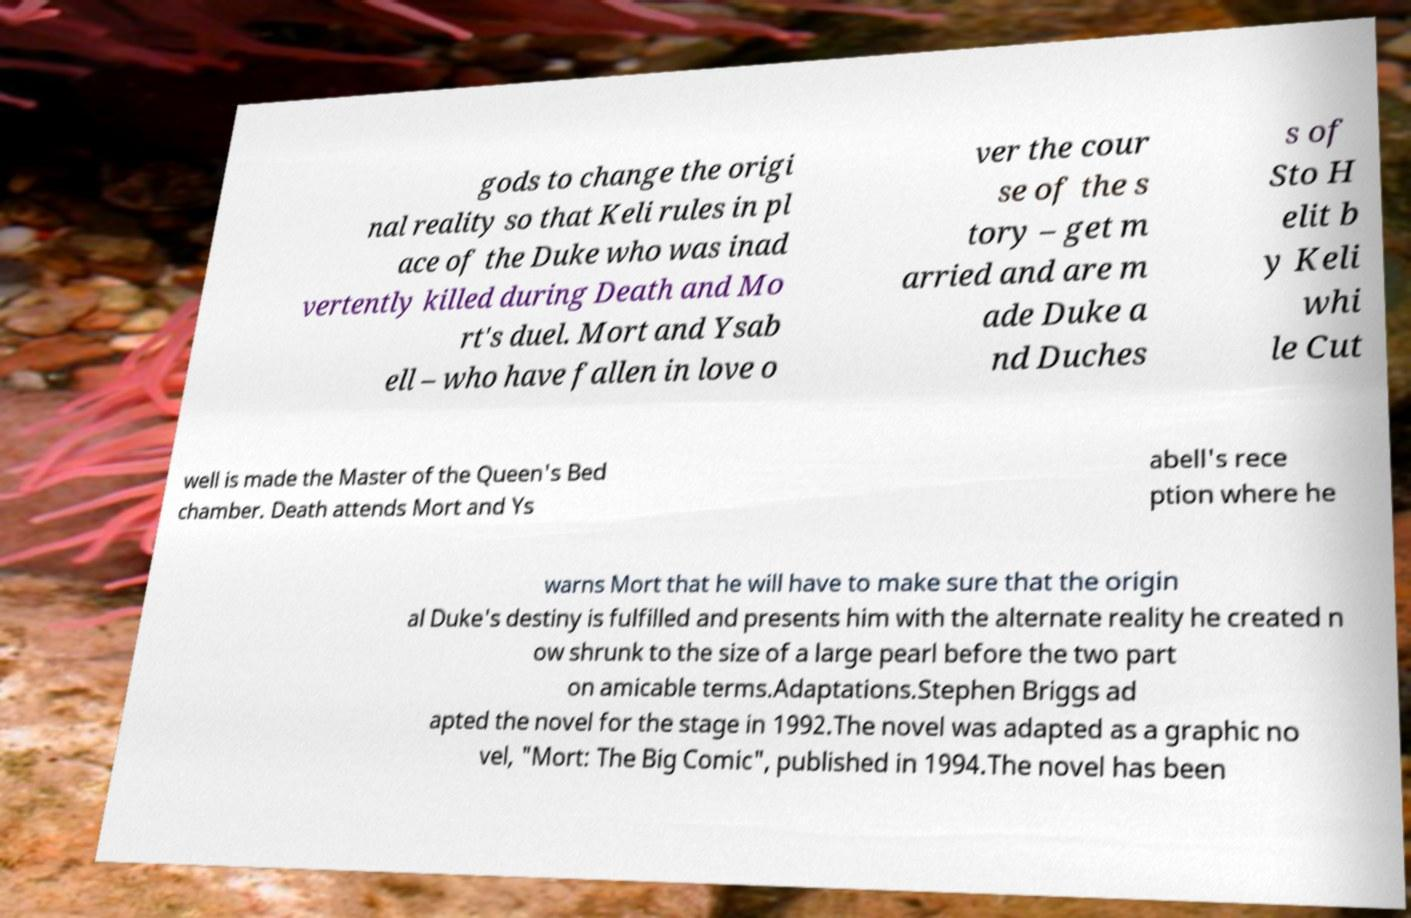What messages or text are displayed in this image? I need them in a readable, typed format. gods to change the origi nal reality so that Keli rules in pl ace of the Duke who was inad vertently killed during Death and Mo rt's duel. Mort and Ysab ell – who have fallen in love o ver the cour se of the s tory – get m arried and are m ade Duke a nd Duches s of Sto H elit b y Keli whi le Cut well is made the Master of the Queen's Bed chamber. Death attends Mort and Ys abell's rece ption where he warns Mort that he will have to make sure that the origin al Duke's destiny is fulfilled and presents him with the alternate reality he created n ow shrunk to the size of a large pearl before the two part on amicable terms.Adaptations.Stephen Briggs ad apted the novel for the stage in 1992.The novel was adapted as a graphic no vel, "Mort: The Big Comic", published in 1994.The novel has been 